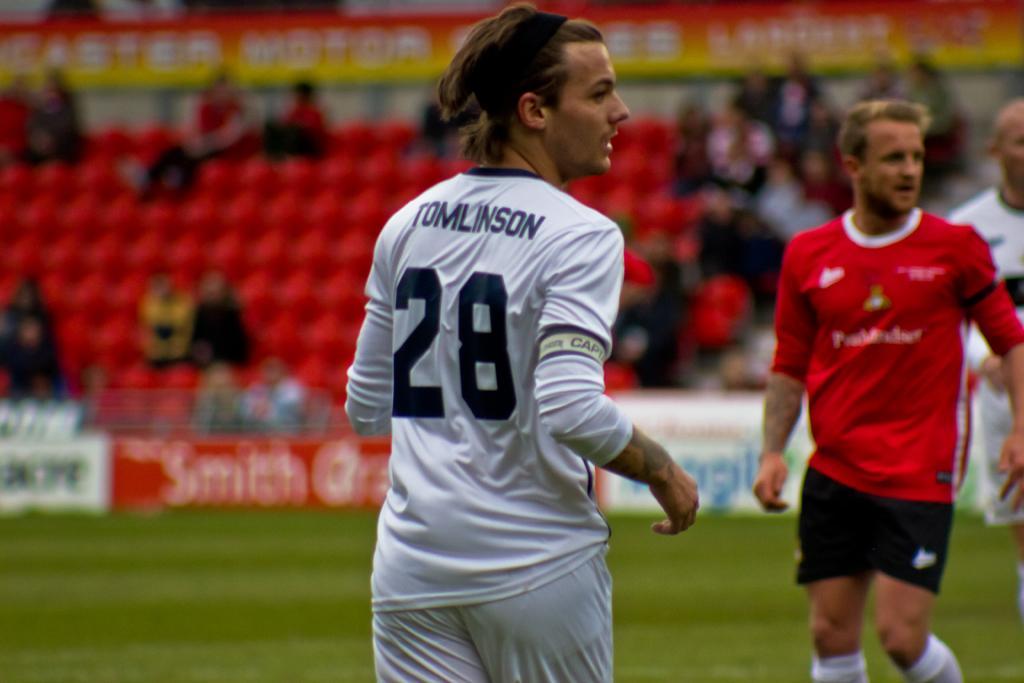Could you give a brief overview of what you see in this image? In this image we can see sportspeople. In the background there are bleachers and we can see people sitting. There are boards. 